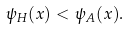<formula> <loc_0><loc_0><loc_500><loc_500>\psi _ { H } ( x ) < \psi _ { A } ( x ) .</formula> 